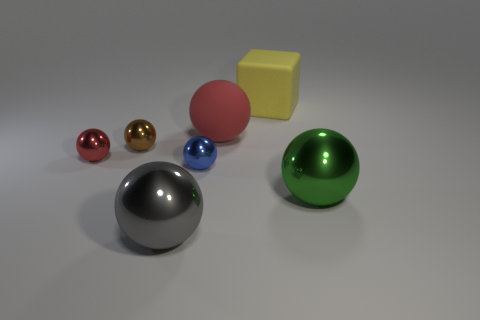Subtract all large metal balls. How many balls are left? 4 Add 2 big brown balls. How many objects exist? 9 Subtract 1 spheres. How many spheres are left? 5 Add 7 blue things. How many blue things exist? 8 Subtract all green spheres. How many spheres are left? 5 Subtract 1 yellow cubes. How many objects are left? 6 Subtract all balls. How many objects are left? 1 Subtract all brown cubes. Subtract all red spheres. How many cubes are left? 1 Subtract all yellow blocks. How many purple spheres are left? 0 Subtract all large things. Subtract all cyan matte things. How many objects are left? 3 